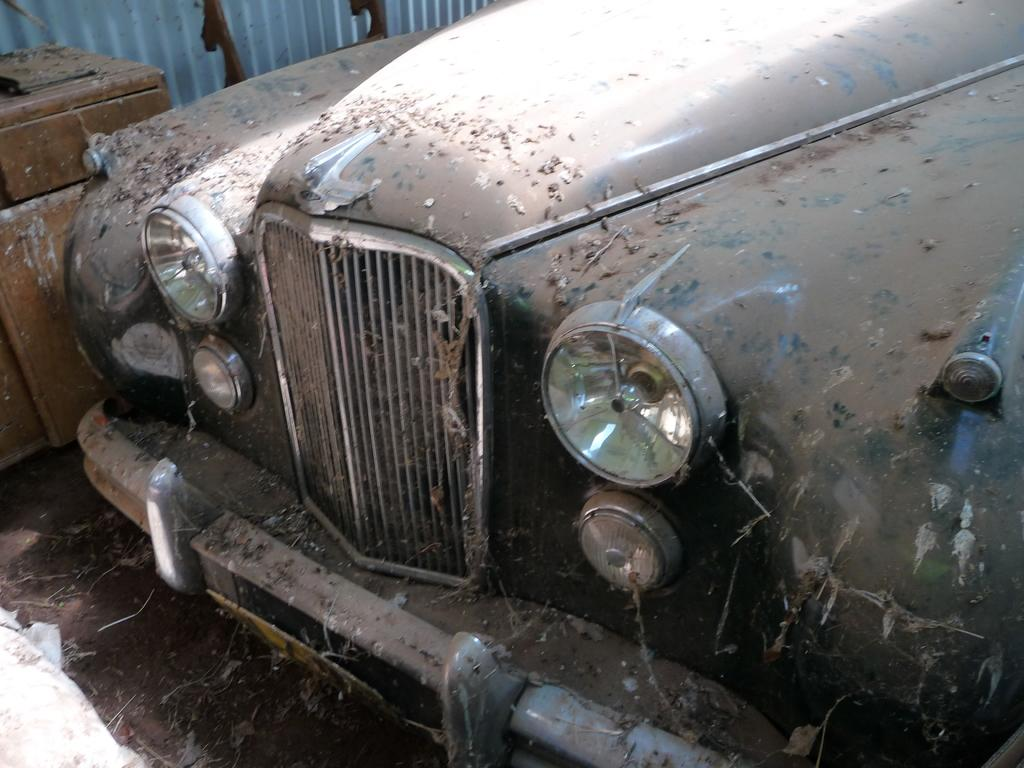What is located on the ground in the image? There is a vehicle on the ground in the image. How does the vehicle appear in the image? The vehicle has dust on it. What can be seen on the left side of the image? There is a wooden object and a metal sheet on the left side. Are there any other objects on the ground on the left side? Yes, there is another object on the ground on the left side. What type of substance is being skated on by the spotted animal in the image? There is no spotted animal or skating activity present in the image. 